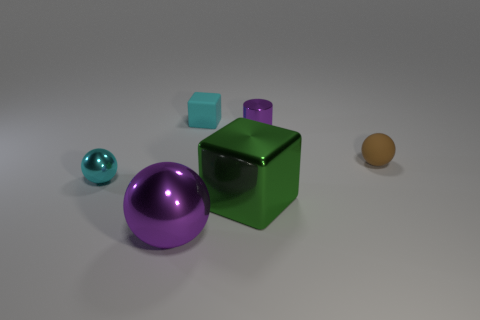There is a ball that is the same color as the shiny cylinder; what size is it?
Your response must be concise. Large. Are there more large purple shiny objects than small spheres?
Give a very brief answer. No. How many brown shiny blocks have the same size as the cyan matte block?
Provide a succinct answer. 0. There is a metallic object that is the same color as the rubber block; what is its shape?
Provide a succinct answer. Sphere. What number of objects are either tiny objects that are on the right side of the big green cube or large purple metallic balls?
Keep it short and to the point. 3. Is the number of purple metal balls less than the number of blocks?
Your response must be concise. Yes. There is a big object that is made of the same material as the purple ball; what is its shape?
Your response must be concise. Cube. Are there any big green shiny things to the left of the tiny metal sphere?
Your answer should be very brief. No. Is the number of large balls that are behind the big cube less than the number of large things?
Your answer should be very brief. Yes. What material is the large green cube?
Give a very brief answer. Metal. 